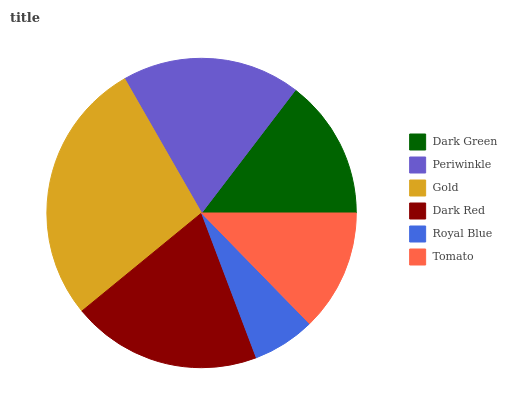Is Royal Blue the minimum?
Answer yes or no. Yes. Is Gold the maximum?
Answer yes or no. Yes. Is Periwinkle the minimum?
Answer yes or no. No. Is Periwinkle the maximum?
Answer yes or no. No. Is Periwinkle greater than Dark Green?
Answer yes or no. Yes. Is Dark Green less than Periwinkle?
Answer yes or no. Yes. Is Dark Green greater than Periwinkle?
Answer yes or no. No. Is Periwinkle less than Dark Green?
Answer yes or no. No. Is Periwinkle the high median?
Answer yes or no. Yes. Is Dark Green the low median?
Answer yes or no. Yes. Is Dark Red the high median?
Answer yes or no. No. Is Gold the low median?
Answer yes or no. No. 